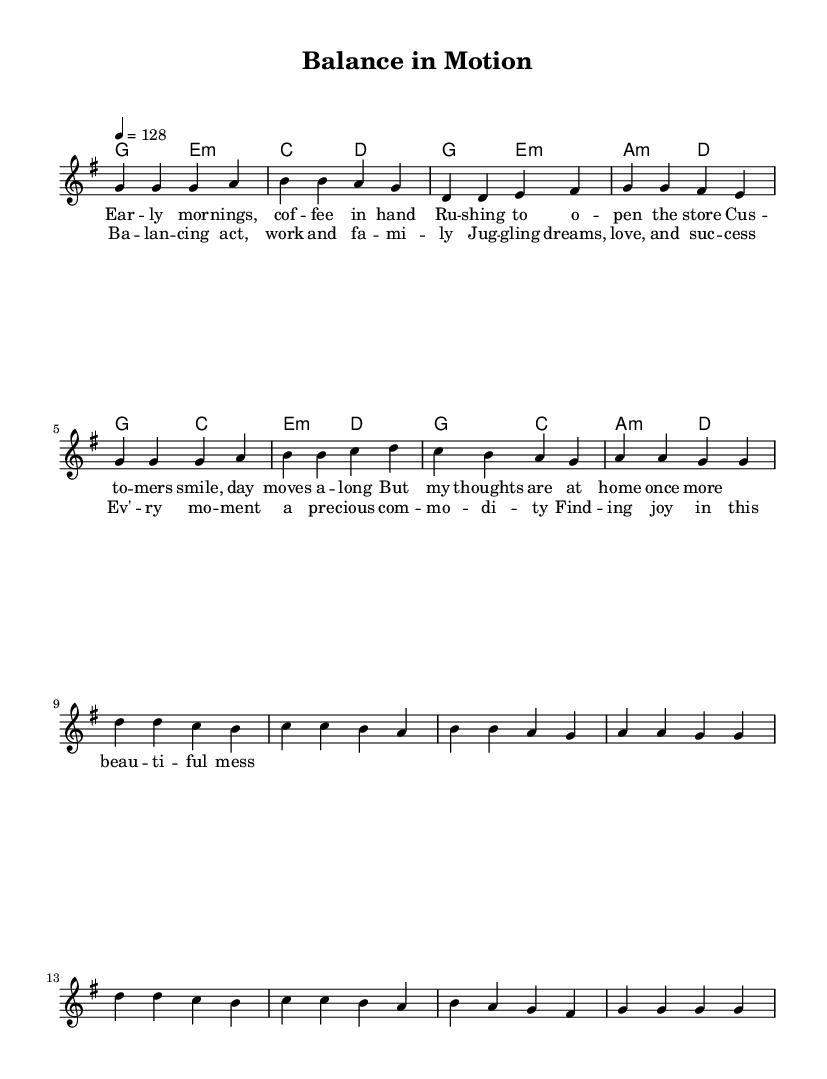What is the key signature of this music? The key signature indicated in the music is G major, which has one sharp (F#). This can be located in the key signature section at the beginning of the staff.
Answer: G major What is the time signature of the piece? The time signature shown is 4/4, meaning there are four beats in each measure and the quarter note receives one beat. This is indicated prominently in the beginning right after the key signature.
Answer: 4/4 What is the tempo marking for this piece? The tempo marking is 128 beats per minute, specified right after the time signature. This means the music should be played at a moderately fast pace.
Answer: 128 How many measures are there in the chorus section? The chorus section contains 8 measures, as counted from the melody part noted in the sheet music. Each measure is separated by vertical bar lines.
Answer: 8 What is the mood or theme of the lyrics based on their content? The lyrics reflect a positive and uplifting theme about balancing work and family life, with expressions of joy in the chaos it brings. This can be inferred from the lyrics detailed in the sheet music.
Answer: Uplifting What chord follows the G major chord in the verse section? The chord that follows the G major chord in the verse section is E minor, as indicated in the chord changes listed in the harmonies section of the sheet music.
Answer: E minor Which lyrical line emphasizes the concept of juggling roles? The lyrical line "Juggling dreams, love, and success" from the chorus specifically emphasizes the balancing act of managing various responsibilities and aspirations. This can be clearly identified in the lyrics provided.
Answer: Juggling dreams, love, and success 